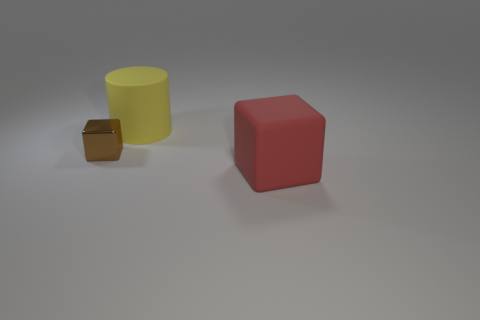Subtract all green cylinders. Subtract all red spheres. How many cylinders are left? 1 Add 3 tiny brown cubes. How many objects exist? 6 Subtract all cylinders. How many objects are left? 2 Add 2 yellow matte cylinders. How many yellow matte cylinders are left? 3 Add 2 small things. How many small things exist? 3 Subtract 0 gray cubes. How many objects are left? 3 Subtract all large yellow rubber cylinders. Subtract all big green metal things. How many objects are left? 2 